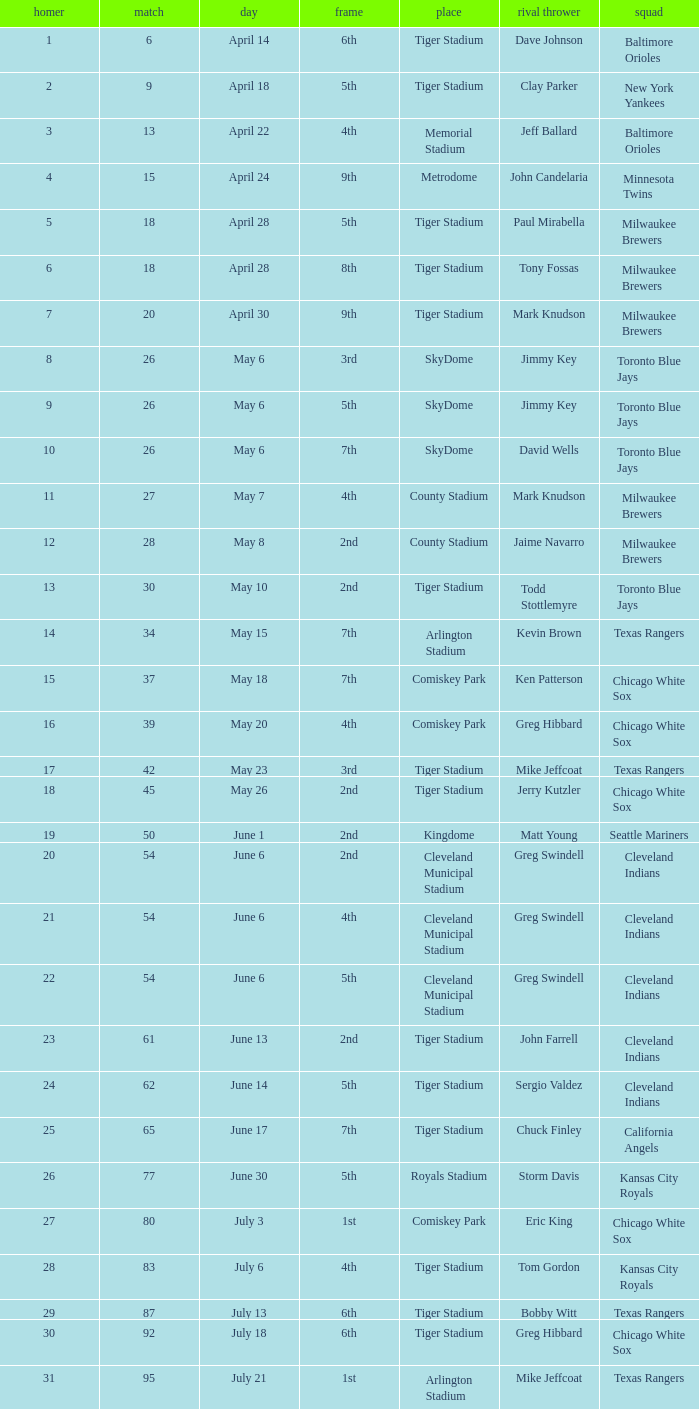What date was the game at Comiskey Park and had a 4th Inning? May 20. 